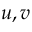<formula> <loc_0><loc_0><loc_500><loc_500>u , v</formula> 